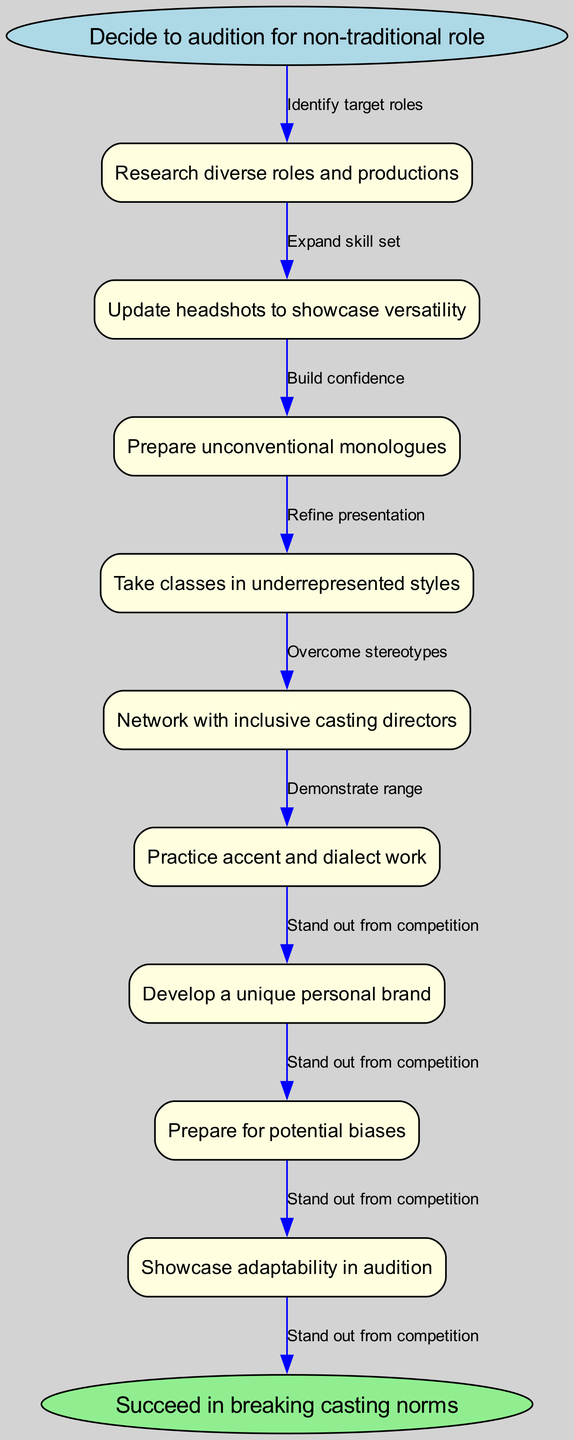What is the first step in the audition preparation process? The diagram starts with the node labeled "Decide to audition for non-traditional role," which indicates the beginning of the process. Therefore, the first step is to make this decision.
Answer: Decide to audition for non-traditional role How many nodes are there in the diagram? The diagram contains the start node, eight intermediate nodes, and one end node, totaling ten nodes.
Answer: 10 What is the last node in the flowchart? The last node, which connects to the end of the process, is labeled "Succeed in breaking casting norms." Thus, this is the final step in the flowchart.
Answer: Succeed in breaking casting norms What connection leads from "Practice accent and dialect work"? From the node labeled "Practice accent and dialect work," the flow leads to the next node "Develop a unique personal brand," connected by the corresponding edge in the diagram.
Answer: Develop a unique personal brand Which node requires overcoming stereotypes? The node "Prepare for potential biases" directly indicates the necessity for overcoming stereotypes as part of the preparation process. This highlights the importance of addressing and challenging biases.
Answer: Prepare for potential biases How many edges are used to connect the nodes? There are nine connections, or edges, in the flowchart. This includes connections between all ten nodes, indicating the relationships and flow from start to end.
Answer: 9 What skill set should be expanded according to the diagram? The preparation emphasizes the importance of expanding the skill set with the node labeled "Expand skill set," indicating a focus on acquiring diverse skills for auditioning effectively for non-traditional roles.
Answer: Expand skill set Which nodes are connected sequentially without other nodes in between? The nodes "Prepare unconventional monologues" and "Take classes in underrepresented styles" are connected sequentially without any intervening nodes, showing a direct flow of preparation stages.
Answer: Prepare unconventional monologues, Take classes in underrepresented styles What is the relationship between "Network with inclusive casting directors" and "Showcase adaptability in audition"? The connection between these two nodes is established by the flow of preparation, with "Network with inclusive casting directors" preceding "Showcase adaptability in audition." This indicates that networking is an important step before adapting in auditions.
Answer: Network with inclusive casting directors, Showcase adaptability in audition 